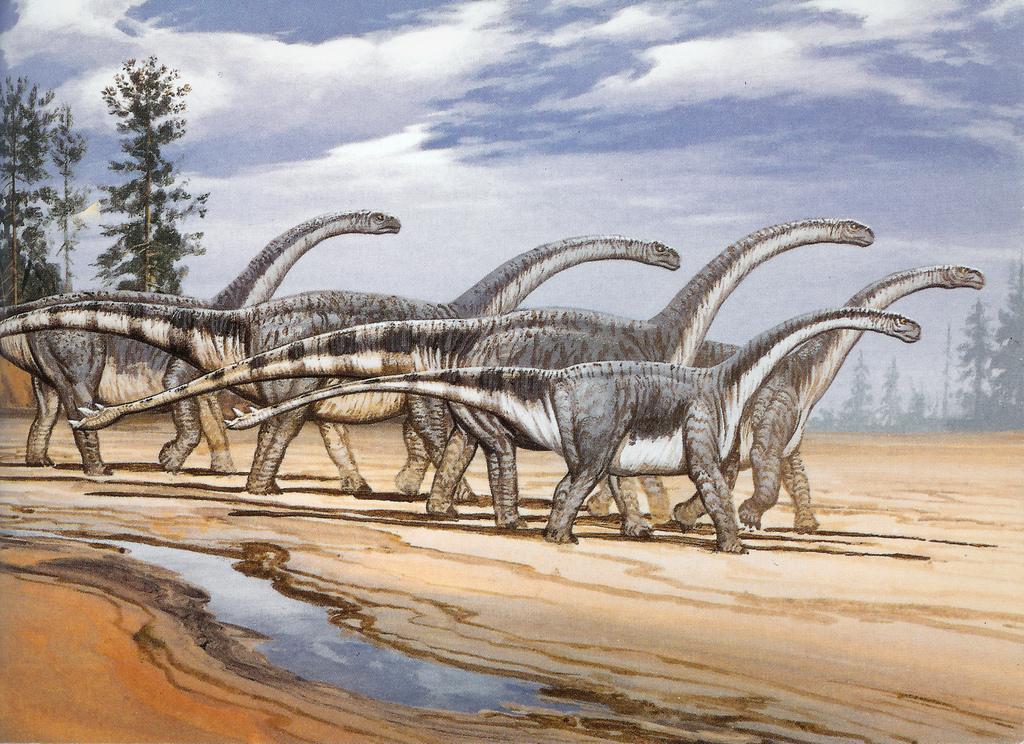What type of visual is depicted in the image? The image appears to be a poster. What is the main subject of the poster? There are dinosaurs in the center of the poster. What can be seen in the background of the poster? There are trees and sky visible in the background of the poster. What is present at the bottom side of the poster? There is water at the bottom side of the poster. How many cherries are hanging from the trees in the image? There are no cherries present in the image; the trees in the background are not specified as fruit-bearing trees. 